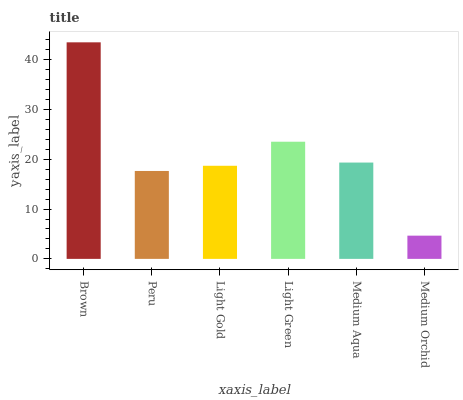Is Medium Orchid the minimum?
Answer yes or no. Yes. Is Brown the maximum?
Answer yes or no. Yes. Is Peru the minimum?
Answer yes or no. No. Is Peru the maximum?
Answer yes or no. No. Is Brown greater than Peru?
Answer yes or no. Yes. Is Peru less than Brown?
Answer yes or no. Yes. Is Peru greater than Brown?
Answer yes or no. No. Is Brown less than Peru?
Answer yes or no. No. Is Medium Aqua the high median?
Answer yes or no. Yes. Is Light Gold the low median?
Answer yes or no. Yes. Is Light Green the high median?
Answer yes or no. No. Is Light Green the low median?
Answer yes or no. No. 